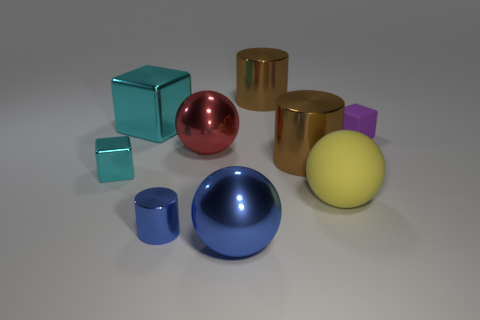Subtract all big cylinders. How many cylinders are left? 1 Subtract all red spheres. How many spheres are left? 2 Add 3 red balls. How many red balls exist? 4 Add 1 shiny cylinders. How many objects exist? 10 Subtract 0 cyan spheres. How many objects are left? 9 Subtract all cylinders. How many objects are left? 6 Subtract 1 balls. How many balls are left? 2 Subtract all gray balls. Subtract all purple cylinders. How many balls are left? 3 Subtract all cyan blocks. How many purple cylinders are left? 0 Subtract all big red metal things. Subtract all gray metal blocks. How many objects are left? 8 